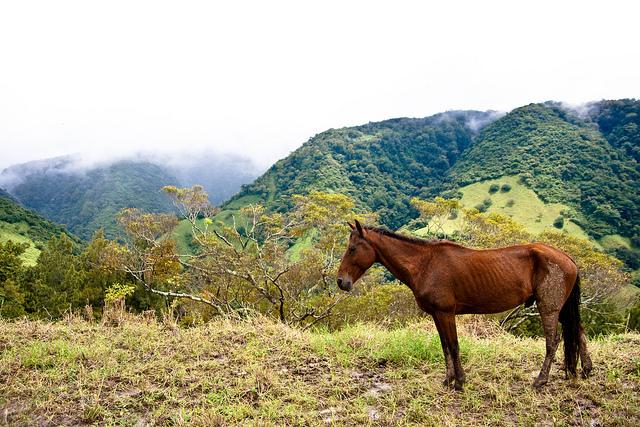Where is the horse with white legs?
Keep it brief. No horse with white legs. Is this horse male?
Short answer required. Yes. What condition is the horse in?
Keep it brief. Thin. What is the horse doing?
Write a very short answer. Standing. What is behind the horse?
Short answer required. Hills. 